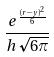<formula> <loc_0><loc_0><loc_500><loc_500>\frac { e ^ { \frac { ( r - y ) ^ { 2 } } { 6 } } } { h \sqrt { 6 \pi } }</formula> 